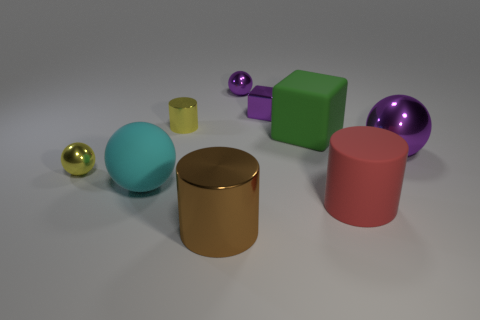Add 1 tiny green matte things. How many objects exist? 10 Subtract all balls. How many objects are left? 5 Add 7 large rubber spheres. How many large rubber spheres are left? 8 Add 8 tiny purple things. How many tiny purple things exist? 10 Subtract 0 cyan cylinders. How many objects are left? 9 Subtract all cyan metal cylinders. Subtract all rubber cylinders. How many objects are left? 8 